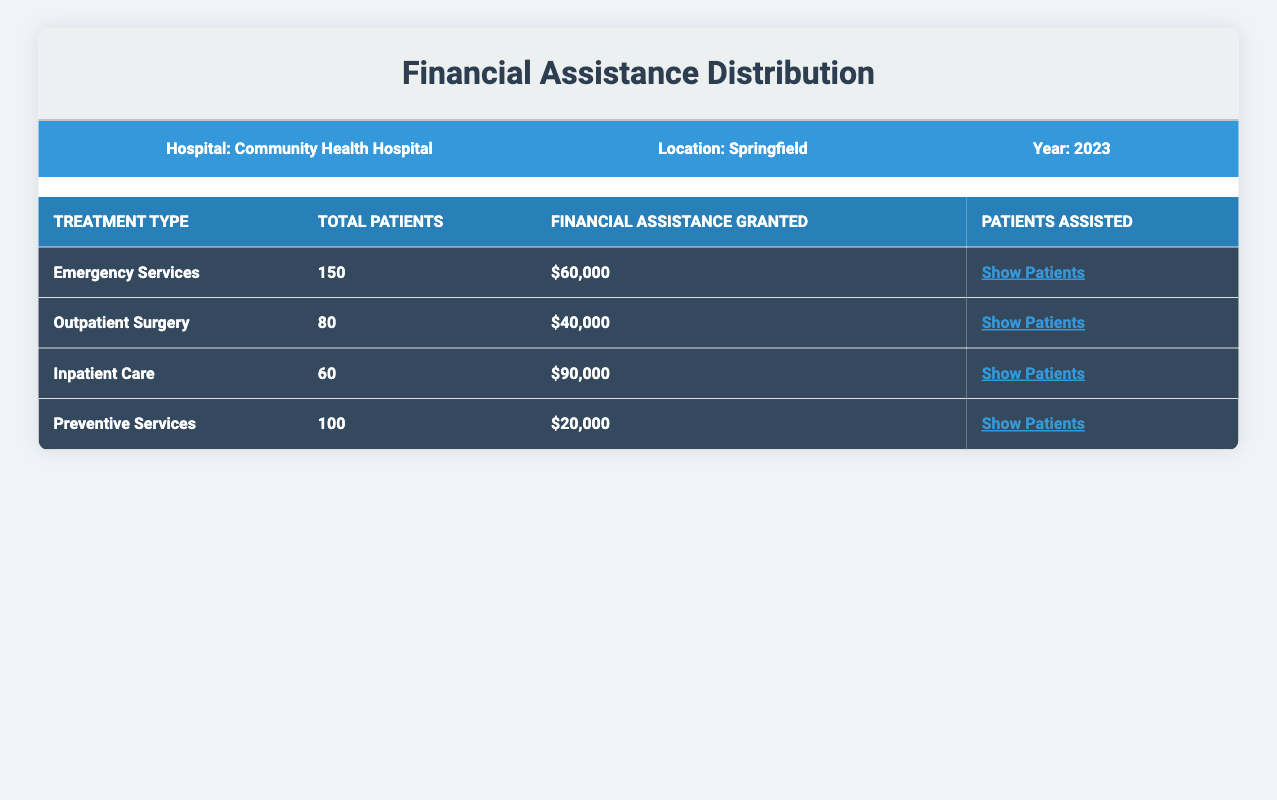What is the total financial assistance granted for Emergency Services? The table indicates that for Emergency Services, the total financial assistance granted is listed as $60,000.
Answer: $60,000 How many patients received financial assistance for Outpatient Surgery? According to the table, the total number of patients who received financial assistance for Outpatient Surgery is 2 as indicated in the "Patients Assisted" section.
Answer: 2 What is the total amount of financial assistance granted for all treatment types combined? Adding the financial assistance granted for all treatment types yields the following: Emergency Services ($60,000) + Outpatient Surgery ($40,000) + Inpatient Care ($90,000) + Preventive Services ($20,000) = $210,000.
Answer: $210,000 Did the hospital provide more financial assistance for Inpatient Care than for Emergency Services? Comparing the two treatment types, Inpatient Care received $90,000 while Emergency Services received $60,000. Therefore, the hospital provided more financial assistance for Inpatient Care than for Emergency Services.
Answer: Yes What is the average financial assistance amount granted per patient for Inpatient Care? The total financial assistance for Inpatient Care is $90,000, and the number of patients assisted is 3. To calculate the average, divide $90,000 by 3, which equals $30,000 per patient.
Answer: $30,000 How much was the financial assistance granted for Preventive Services compared to Outpatient Surgery? Preventive Services received $20,000 and Outpatient Surgery received $40,000. Since $20,000 is less than $40,000, Preventive Services received less financial assistance than Outpatient Surgery.
Answer: Yes What is the total number of patients who received financial assistance across all treatment types? The table lists the patients assisted as follows: Emergency Services (3), Outpatient Surgery (2), Inpatient Care (3), and Preventive Services (2). Adding these gives a total of 3 + 2 + 3 + 2 = 10 patients.
Answer: 10 Which treatment type had the highest financial assistance granted, and what was that amount? Looking at the financial assistance granted, Inpatient Care received the most at $90,000, compared to the other treatment types.
Answer: Inpatient Care, $90,000 How much financial assistance was granted for each type of treatment if the total was divided based on the number of patients assisted? Financial assistance per patient assisted is calculated as follows: Emergency Services ($60,000 / 3 patients = $20,000); Outpatient Surgery ($40,000 / 2 patients = $20,000); Inpatient Care ($90,000 / 3 patients = $30,000); Preventive Services ($20,000 / 2 patients = $10,000). The amounts are $20,000, $20,000, $30,000, and $10,000 respectively.
Answer: $20,000, $20,000, $30,000, $10,000 